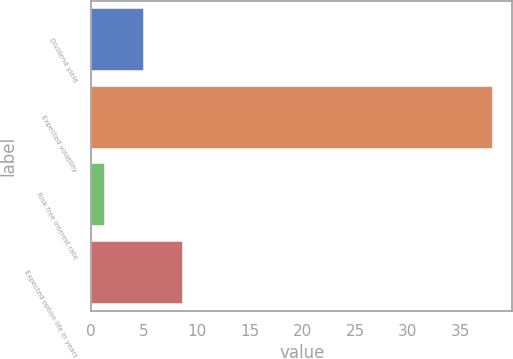Convert chart. <chart><loc_0><loc_0><loc_500><loc_500><bar_chart><fcel>Dividend yield<fcel>Expected volatility<fcel>Risk free interest rate<fcel>Expected option life in years<nl><fcel>4.88<fcel>38<fcel>1.2<fcel>8.56<nl></chart> 